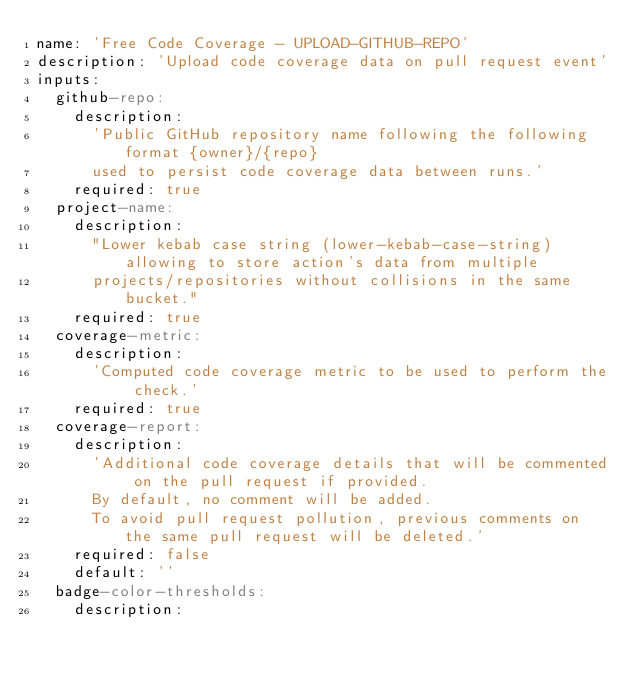<code> <loc_0><loc_0><loc_500><loc_500><_YAML_>name: 'Free Code Coverage - UPLOAD-GITHUB-REPO'
description: 'Upload code coverage data on pull request event'
inputs:
  github-repo:
    description:
      'Public GitHub repository name following the following format {owner}/{repo}
      used to persist code coverage data between runs.'
    required: true
  project-name:
    description:
      "Lower kebab case string (lower-kebab-case-string) allowing to store action's data from multiple
      projects/repositories without collisions in the same bucket."
    required: true
  coverage-metric:
    description:
      'Computed code coverage metric to be used to perform the check.'
    required: true
  coverage-report:
    description:
      'Additional code coverage details that will be commented on the pull request if provided.
      By default, no comment will be added.
      To avoid pull request pollution, previous comments on the same pull request will be deleted.'
    required: false
    default: ''
  badge-color-thresholds:
    description:</code> 